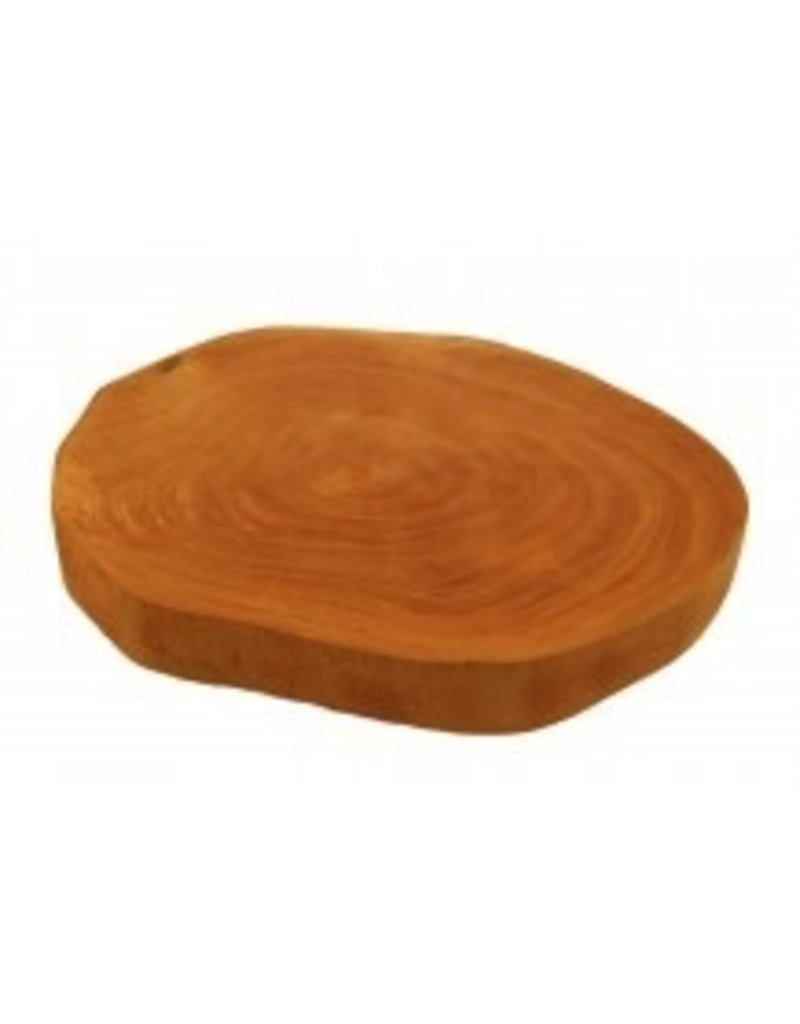Can you estimate the age of the tree from which this wooden slab was cut by analyzing the growth rings visible here? Counting the visible growth rings on the slab offers a rough estimate of the tree’s age, as each ring typically represents one year of growth. Precise age estimation could, however, require examination of the entire cross-section of the trunk. Also, factors like the species of tree and growth conditions affect the accuracy of such age estimates. 